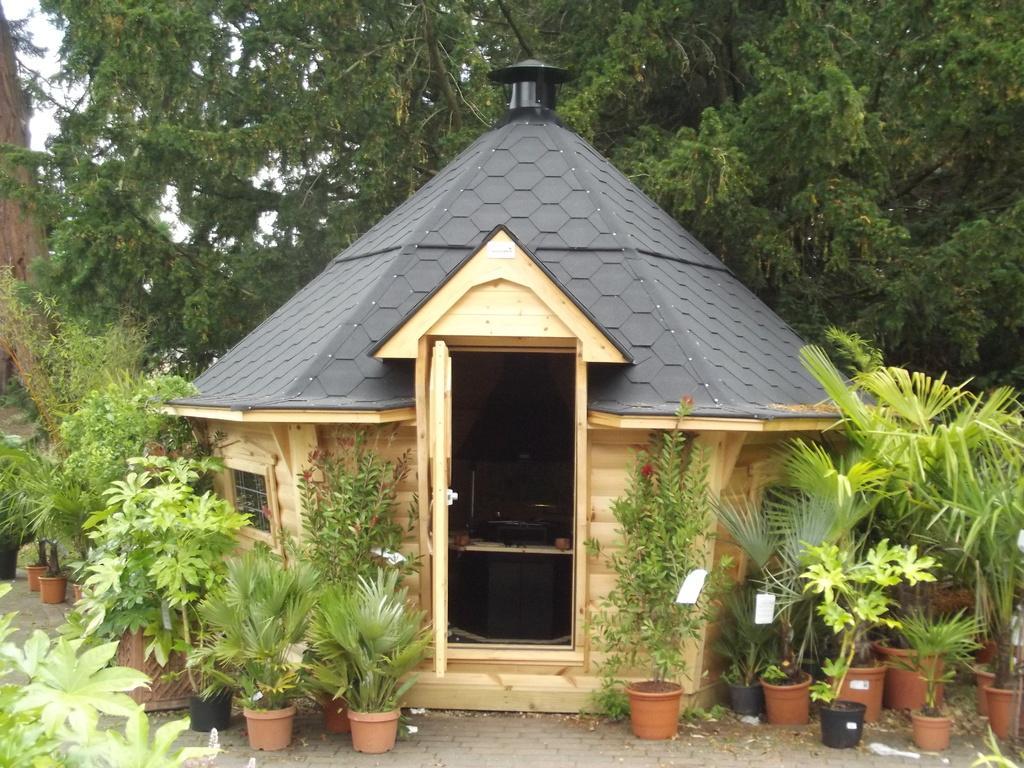Could you give a brief overview of what you see in this image? In this picture we can see a hut and in front of the but there are plants in the pots. Behind the hut there are trees and a sky. 